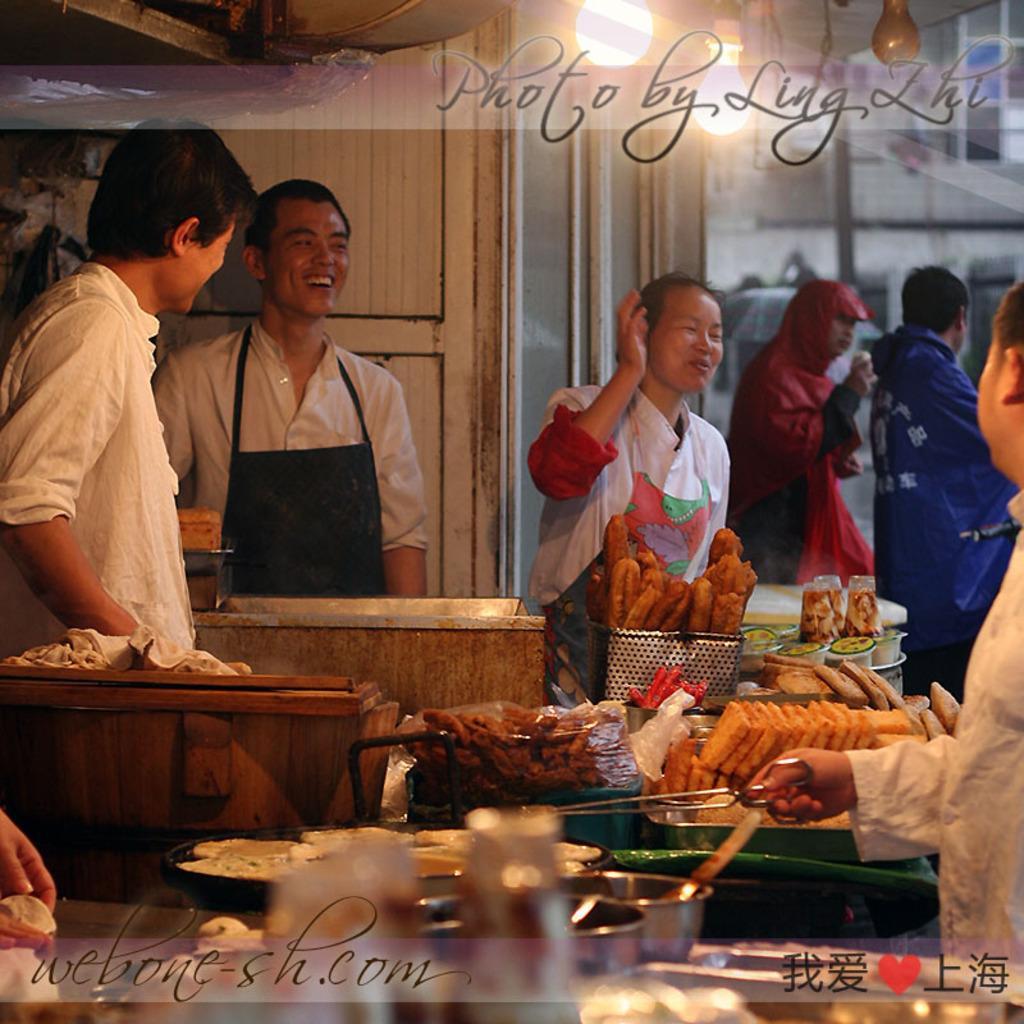Describe this image in one or two sentences. In this image in the center there are a group of people, and at the bottom of the image there are some food items, baskets, breads, and some bowls, spatulas and one person is holding a scissor. And in the background there are two people standing, and there are glass doors and through the doors we could see buildings. At the top of the image there are lights and there is a text. 